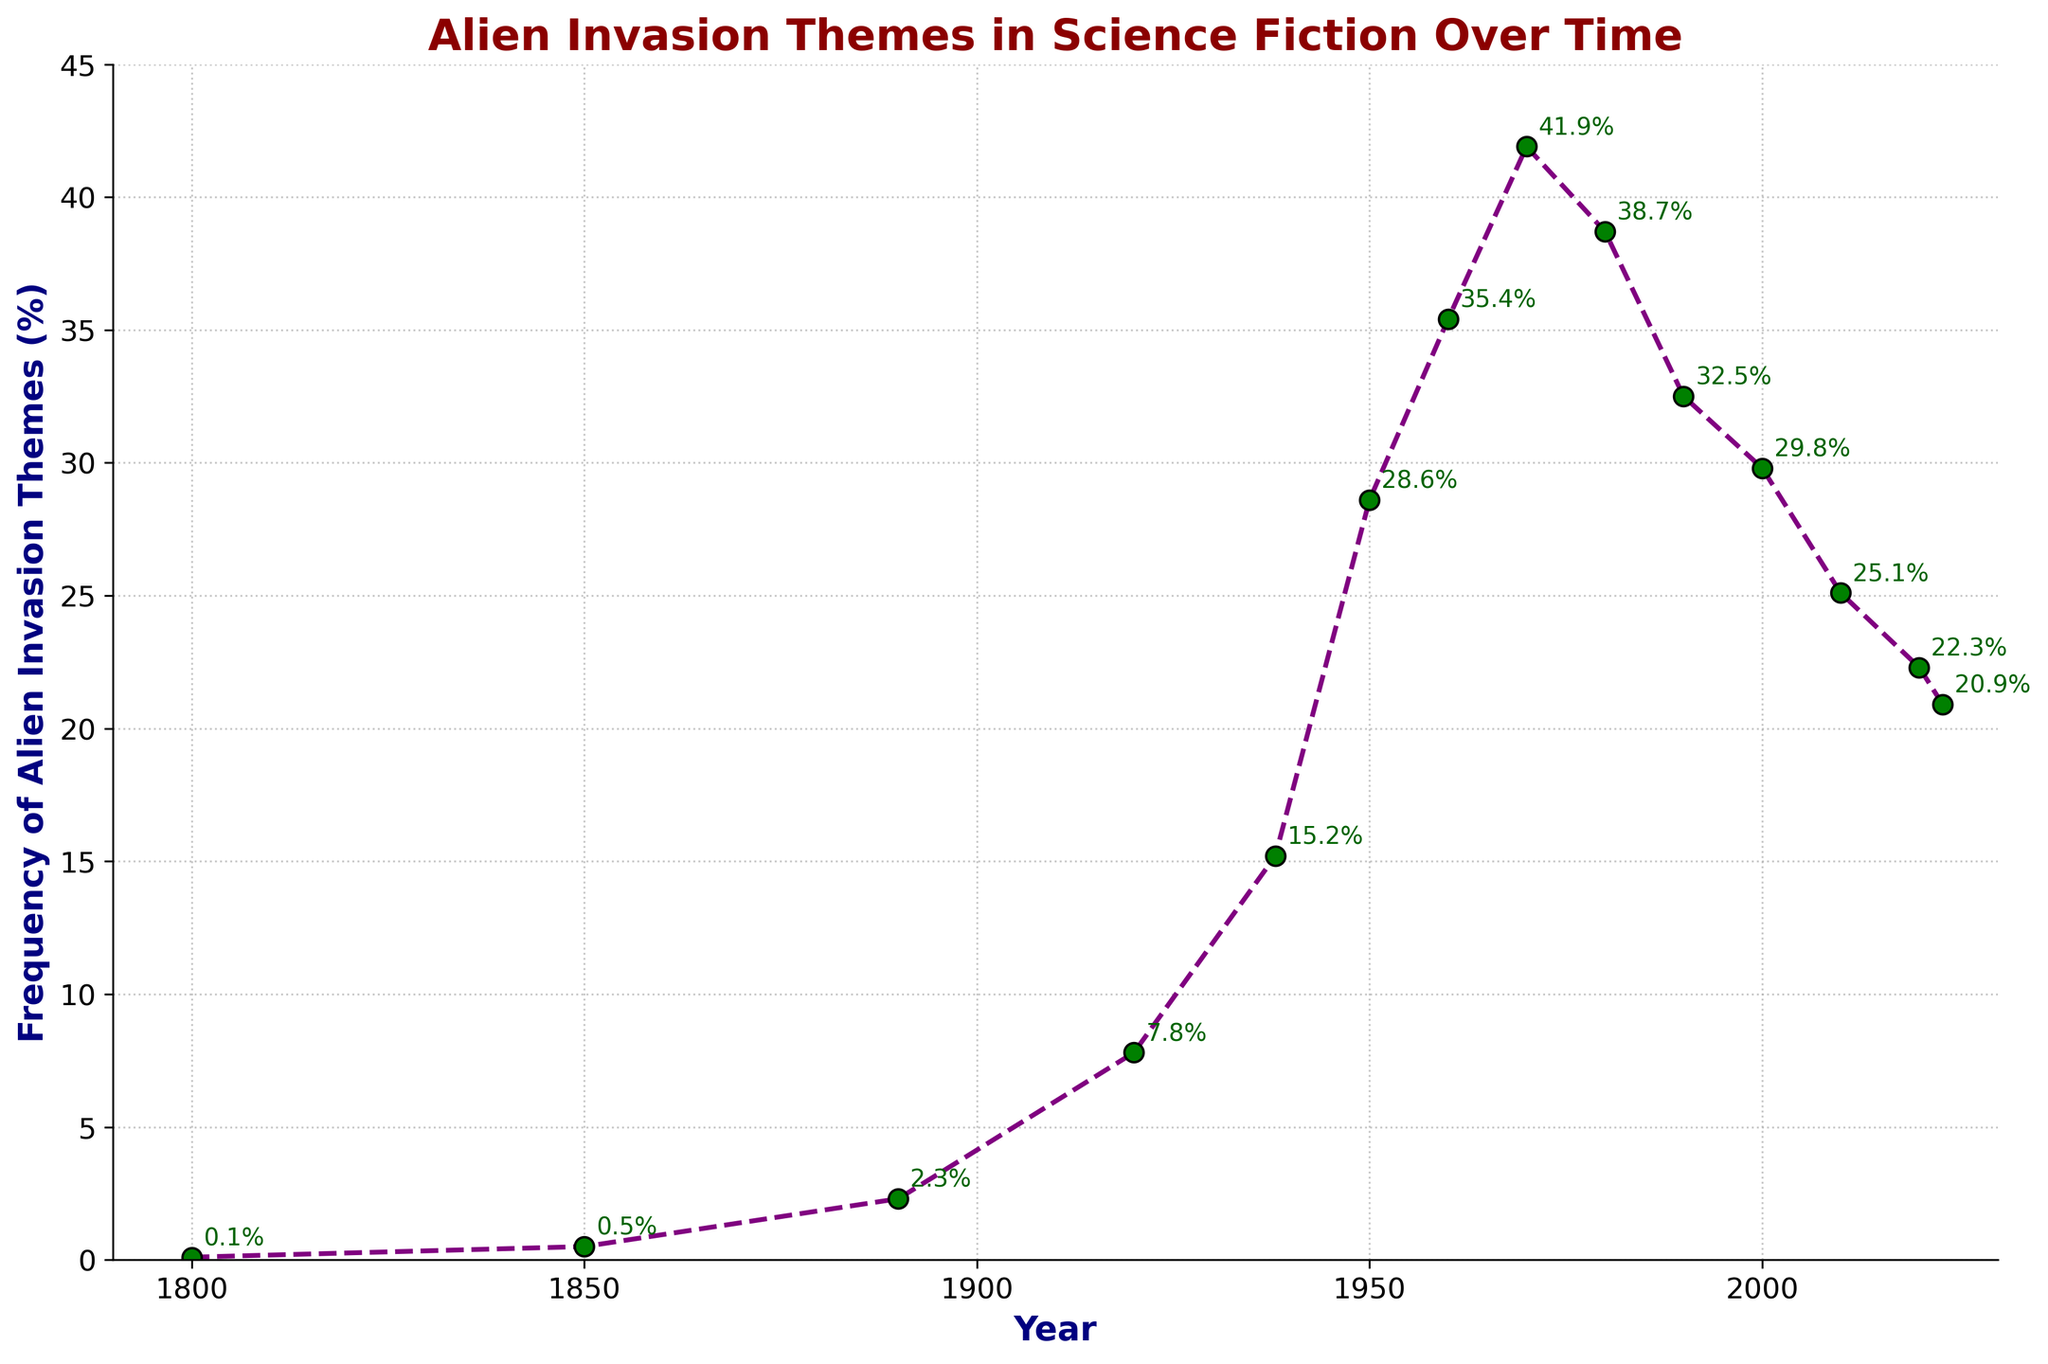What is the highest frequency of alien invasion themes recorded on the chart? The highest frequency is depicted at the peak of the line, which corresponds to the year 1970 with a value of 41.9%.
Answer: 41.9% What is the overall trend in the frequency of alien invasion themes from 1800 to 2023? The trend shows an overall increase in frequency from 1800 to 1970, followed by a general decline from 1980 to 2023.
Answer: Increase then decrease In what year did the frequency of alien invasion themes first exceed 10%? The frequency first exceeded 10% in the year 1938, as observed by the jump to 15.2%.
Answer: 1938 Compare the frequencies of alien invasion themes in the years 1950 and 2000. Which year had a higher value? By comparing the two points, 1950 had a frequency of 28.6%, while 2000 had a lower frequency of 29.8%.
Answer: 2000 What is the average frequency of alien invasion themes in the years 1800, 1850, and 1890? The frequencies are 0.1%, 0.5%, and 2.3%. The average is calculated as (0.1 + 0.5 + 2.3) / 3 = 0.967%.
Answer: 0.967% By how much did the frequency change between 1938 and 1950? The frequency increased from 15.2% in 1938 to 28.6% in 1950, a difference of 28.6 - 15.2 = 13.4%.
Answer: 13.4% What is the frequency of alien invasion themes in 2020, and how does it compare to 2023? In 2020, the frequency was 22.3%, while in 2023, it decreased to 20.9%. This represents a decline of 22.3 - 20.9 = 1.4%.
Answer: 22.3%, decreased by 1.4% How many years did the frequency of alien invasion themes stay above 30%? The frequency stayed above 30% from 1960 to 1980, so for a total of 21 years.
Answer: 21 years What unique trends or patterns can be observed in the frequency of alien invasion themes between 1960 and 1990? From 1960 (35.4%), there is a steep increase to a peak in 1970 (41.9%), followed by a decline to 32.5% in 1990.
Answer: Increase then decrease Compare the visual appearance of the data points between 1800 and 2023. What unique observation can you make regarding the marker styles or lines? The data points are connected with a dashed line in purple, and each point is marked by a green dot with black edges; annotations are present next to each marker showing the frequency value.
Answer: Green dot markers with frequency annotations 